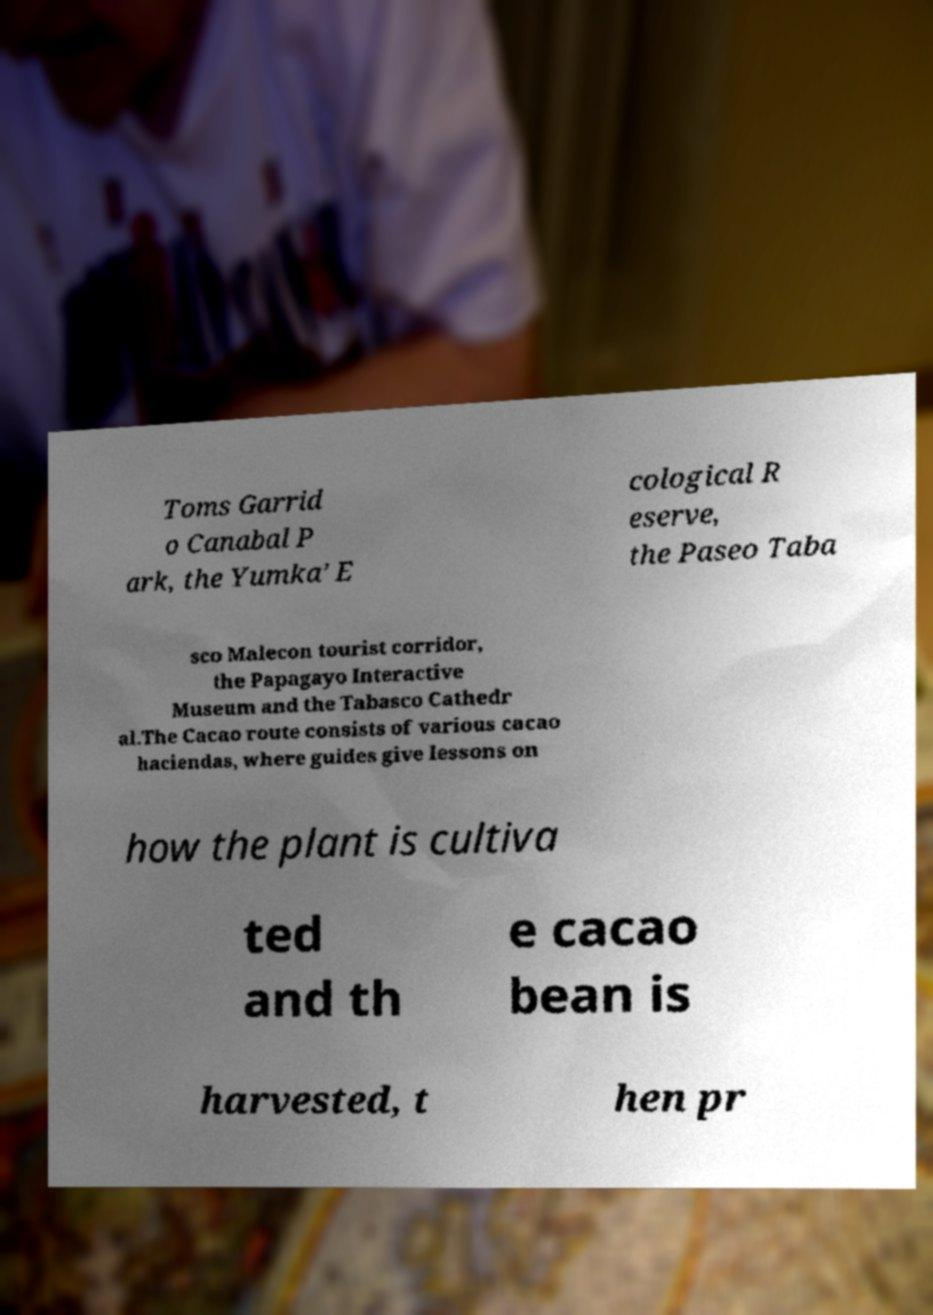Please identify and transcribe the text found in this image. Toms Garrid o Canabal P ark, the Yumka’ E cological R eserve, the Paseo Taba sco Malecon tourist corridor, the Papagayo Interactive Museum and the Tabasco Cathedr al.The Cacao route consists of various cacao haciendas, where guides give lessons on how the plant is cultiva ted and th e cacao bean is harvested, t hen pr 